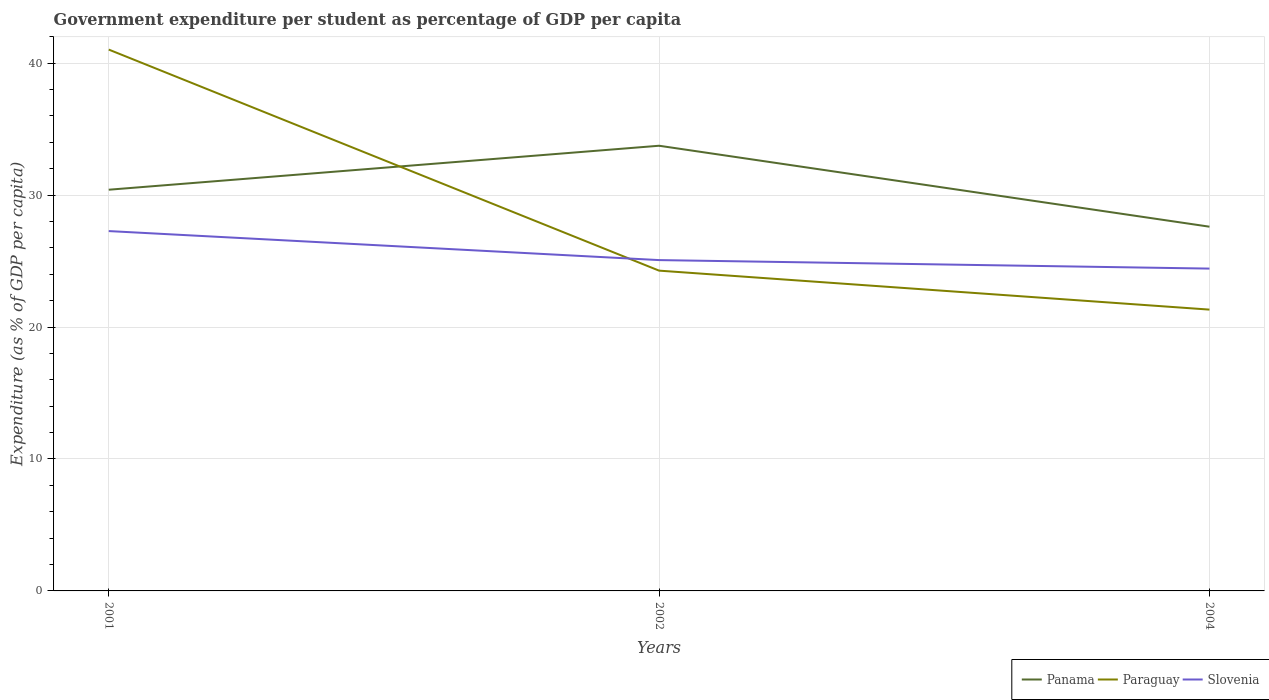Is the number of lines equal to the number of legend labels?
Offer a terse response. Yes. Across all years, what is the maximum percentage of expenditure per student in Panama?
Your response must be concise. 27.61. What is the total percentage of expenditure per student in Slovenia in the graph?
Keep it short and to the point. 2.2. What is the difference between the highest and the second highest percentage of expenditure per student in Slovenia?
Make the answer very short. 2.84. What is the difference between the highest and the lowest percentage of expenditure per student in Panama?
Provide a short and direct response. 1. What is the difference between two consecutive major ticks on the Y-axis?
Offer a very short reply. 10. Does the graph contain grids?
Ensure brevity in your answer.  Yes. Where does the legend appear in the graph?
Keep it short and to the point. Bottom right. What is the title of the graph?
Keep it short and to the point. Government expenditure per student as percentage of GDP per capita. Does "China" appear as one of the legend labels in the graph?
Keep it short and to the point. No. What is the label or title of the X-axis?
Your answer should be very brief. Years. What is the label or title of the Y-axis?
Provide a succinct answer. Expenditure (as % of GDP per capita). What is the Expenditure (as % of GDP per capita) in Panama in 2001?
Make the answer very short. 30.41. What is the Expenditure (as % of GDP per capita) in Paraguay in 2001?
Your answer should be compact. 41.03. What is the Expenditure (as % of GDP per capita) of Slovenia in 2001?
Provide a short and direct response. 27.27. What is the Expenditure (as % of GDP per capita) in Panama in 2002?
Offer a very short reply. 33.74. What is the Expenditure (as % of GDP per capita) in Paraguay in 2002?
Provide a short and direct response. 24.28. What is the Expenditure (as % of GDP per capita) in Slovenia in 2002?
Your response must be concise. 25.08. What is the Expenditure (as % of GDP per capita) in Panama in 2004?
Offer a terse response. 27.61. What is the Expenditure (as % of GDP per capita) of Paraguay in 2004?
Keep it short and to the point. 21.32. What is the Expenditure (as % of GDP per capita) of Slovenia in 2004?
Your response must be concise. 24.43. Across all years, what is the maximum Expenditure (as % of GDP per capita) in Panama?
Your answer should be very brief. 33.74. Across all years, what is the maximum Expenditure (as % of GDP per capita) in Paraguay?
Provide a succinct answer. 41.03. Across all years, what is the maximum Expenditure (as % of GDP per capita) in Slovenia?
Give a very brief answer. 27.27. Across all years, what is the minimum Expenditure (as % of GDP per capita) in Panama?
Your answer should be very brief. 27.61. Across all years, what is the minimum Expenditure (as % of GDP per capita) in Paraguay?
Provide a succinct answer. 21.32. Across all years, what is the minimum Expenditure (as % of GDP per capita) in Slovenia?
Your response must be concise. 24.43. What is the total Expenditure (as % of GDP per capita) of Panama in the graph?
Make the answer very short. 91.76. What is the total Expenditure (as % of GDP per capita) of Paraguay in the graph?
Your answer should be compact. 86.63. What is the total Expenditure (as % of GDP per capita) of Slovenia in the graph?
Your response must be concise. 76.78. What is the difference between the Expenditure (as % of GDP per capita) of Panama in 2001 and that in 2002?
Your answer should be very brief. -3.33. What is the difference between the Expenditure (as % of GDP per capita) of Paraguay in 2001 and that in 2002?
Your response must be concise. 16.76. What is the difference between the Expenditure (as % of GDP per capita) of Slovenia in 2001 and that in 2002?
Provide a succinct answer. 2.2. What is the difference between the Expenditure (as % of GDP per capita) in Panama in 2001 and that in 2004?
Ensure brevity in your answer.  2.8. What is the difference between the Expenditure (as % of GDP per capita) in Paraguay in 2001 and that in 2004?
Your answer should be very brief. 19.71. What is the difference between the Expenditure (as % of GDP per capita) of Slovenia in 2001 and that in 2004?
Your answer should be very brief. 2.84. What is the difference between the Expenditure (as % of GDP per capita) of Panama in 2002 and that in 2004?
Your response must be concise. 6.14. What is the difference between the Expenditure (as % of GDP per capita) in Paraguay in 2002 and that in 2004?
Offer a very short reply. 2.95. What is the difference between the Expenditure (as % of GDP per capita) in Slovenia in 2002 and that in 2004?
Provide a succinct answer. 0.64. What is the difference between the Expenditure (as % of GDP per capita) in Panama in 2001 and the Expenditure (as % of GDP per capita) in Paraguay in 2002?
Ensure brevity in your answer.  6.13. What is the difference between the Expenditure (as % of GDP per capita) in Panama in 2001 and the Expenditure (as % of GDP per capita) in Slovenia in 2002?
Give a very brief answer. 5.33. What is the difference between the Expenditure (as % of GDP per capita) of Paraguay in 2001 and the Expenditure (as % of GDP per capita) of Slovenia in 2002?
Provide a succinct answer. 15.96. What is the difference between the Expenditure (as % of GDP per capita) of Panama in 2001 and the Expenditure (as % of GDP per capita) of Paraguay in 2004?
Provide a succinct answer. 9.09. What is the difference between the Expenditure (as % of GDP per capita) in Panama in 2001 and the Expenditure (as % of GDP per capita) in Slovenia in 2004?
Offer a very short reply. 5.98. What is the difference between the Expenditure (as % of GDP per capita) of Paraguay in 2001 and the Expenditure (as % of GDP per capita) of Slovenia in 2004?
Ensure brevity in your answer.  16.6. What is the difference between the Expenditure (as % of GDP per capita) in Panama in 2002 and the Expenditure (as % of GDP per capita) in Paraguay in 2004?
Offer a very short reply. 12.42. What is the difference between the Expenditure (as % of GDP per capita) of Panama in 2002 and the Expenditure (as % of GDP per capita) of Slovenia in 2004?
Keep it short and to the point. 9.31. What is the difference between the Expenditure (as % of GDP per capita) in Paraguay in 2002 and the Expenditure (as % of GDP per capita) in Slovenia in 2004?
Your response must be concise. -0.16. What is the average Expenditure (as % of GDP per capita) of Panama per year?
Provide a succinct answer. 30.59. What is the average Expenditure (as % of GDP per capita) of Paraguay per year?
Your answer should be compact. 28.88. What is the average Expenditure (as % of GDP per capita) of Slovenia per year?
Offer a terse response. 25.59. In the year 2001, what is the difference between the Expenditure (as % of GDP per capita) in Panama and Expenditure (as % of GDP per capita) in Paraguay?
Provide a short and direct response. -10.62. In the year 2001, what is the difference between the Expenditure (as % of GDP per capita) of Panama and Expenditure (as % of GDP per capita) of Slovenia?
Your answer should be very brief. 3.13. In the year 2001, what is the difference between the Expenditure (as % of GDP per capita) in Paraguay and Expenditure (as % of GDP per capita) in Slovenia?
Your response must be concise. 13.76. In the year 2002, what is the difference between the Expenditure (as % of GDP per capita) in Panama and Expenditure (as % of GDP per capita) in Paraguay?
Provide a succinct answer. 9.47. In the year 2002, what is the difference between the Expenditure (as % of GDP per capita) of Panama and Expenditure (as % of GDP per capita) of Slovenia?
Provide a succinct answer. 8.67. In the year 2002, what is the difference between the Expenditure (as % of GDP per capita) of Paraguay and Expenditure (as % of GDP per capita) of Slovenia?
Your answer should be compact. -0.8. In the year 2004, what is the difference between the Expenditure (as % of GDP per capita) in Panama and Expenditure (as % of GDP per capita) in Paraguay?
Give a very brief answer. 6.28. In the year 2004, what is the difference between the Expenditure (as % of GDP per capita) of Panama and Expenditure (as % of GDP per capita) of Slovenia?
Ensure brevity in your answer.  3.18. In the year 2004, what is the difference between the Expenditure (as % of GDP per capita) of Paraguay and Expenditure (as % of GDP per capita) of Slovenia?
Your response must be concise. -3.11. What is the ratio of the Expenditure (as % of GDP per capita) of Panama in 2001 to that in 2002?
Provide a succinct answer. 0.9. What is the ratio of the Expenditure (as % of GDP per capita) in Paraguay in 2001 to that in 2002?
Keep it short and to the point. 1.69. What is the ratio of the Expenditure (as % of GDP per capita) in Slovenia in 2001 to that in 2002?
Your response must be concise. 1.09. What is the ratio of the Expenditure (as % of GDP per capita) of Panama in 2001 to that in 2004?
Make the answer very short. 1.1. What is the ratio of the Expenditure (as % of GDP per capita) of Paraguay in 2001 to that in 2004?
Make the answer very short. 1.92. What is the ratio of the Expenditure (as % of GDP per capita) of Slovenia in 2001 to that in 2004?
Offer a very short reply. 1.12. What is the ratio of the Expenditure (as % of GDP per capita) of Panama in 2002 to that in 2004?
Give a very brief answer. 1.22. What is the ratio of the Expenditure (as % of GDP per capita) in Paraguay in 2002 to that in 2004?
Make the answer very short. 1.14. What is the ratio of the Expenditure (as % of GDP per capita) of Slovenia in 2002 to that in 2004?
Ensure brevity in your answer.  1.03. What is the difference between the highest and the second highest Expenditure (as % of GDP per capita) in Panama?
Offer a terse response. 3.33. What is the difference between the highest and the second highest Expenditure (as % of GDP per capita) of Paraguay?
Your response must be concise. 16.76. What is the difference between the highest and the lowest Expenditure (as % of GDP per capita) of Panama?
Keep it short and to the point. 6.14. What is the difference between the highest and the lowest Expenditure (as % of GDP per capita) of Paraguay?
Give a very brief answer. 19.71. What is the difference between the highest and the lowest Expenditure (as % of GDP per capita) in Slovenia?
Give a very brief answer. 2.84. 